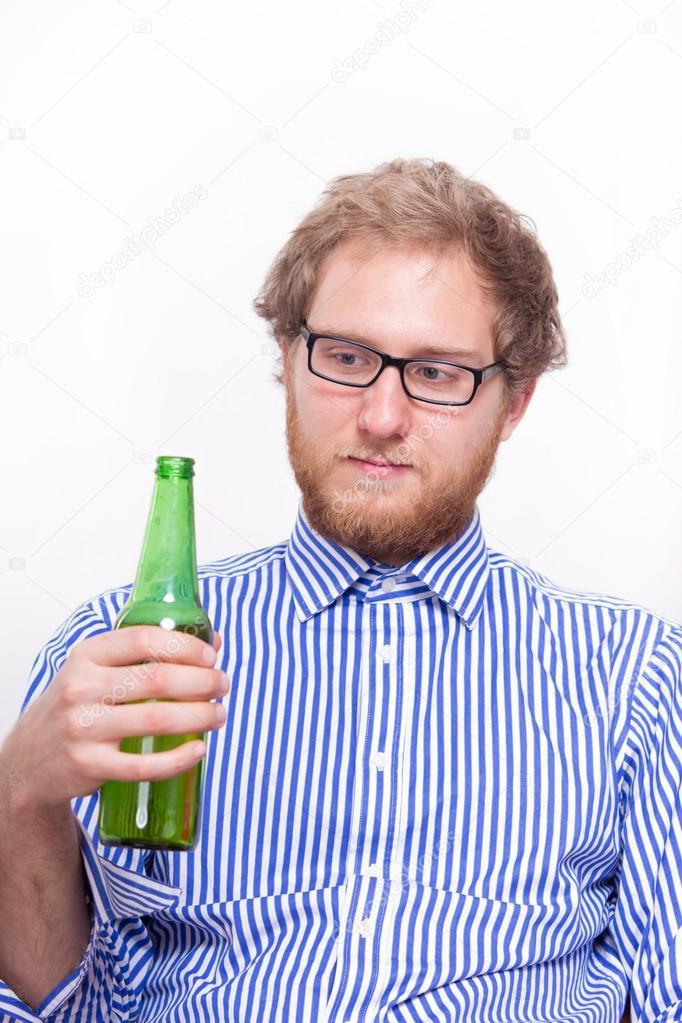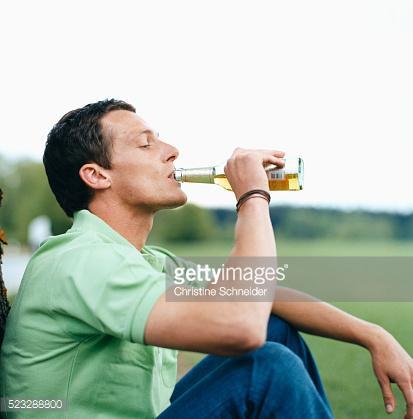The first image is the image on the left, the second image is the image on the right. Assess this claim about the two images: "The man in the image on the left is holding a green bottle.". Correct or not? Answer yes or no. Yes. The first image is the image on the left, the second image is the image on the right. Considering the images on both sides, is "There is a total of three bottles or cans of beer." valid? Answer yes or no. No. 